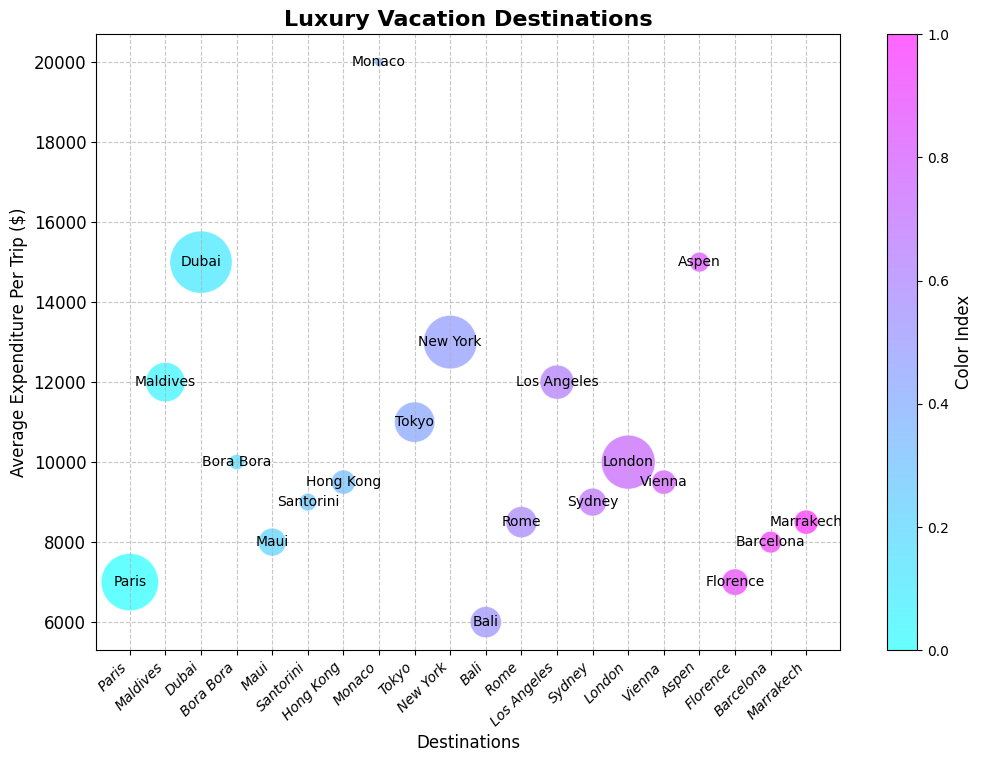Which destination has the highest average expenditure per trip? Identify the bubble with the highest position on the y-axis. Dubai has the highest y-value, representing the average expenditure per trip.
Answer: Dubai Which destination has the most five-star hotels? Identify the bubble with the largest size. Dubai’s bubble is the largest, representing the highest number of five-star hotels.
Answer: Dubai Compare the average expenditure per trip between Monaco and New York. Which is higher? Locate the bubbles for Monaco and New York and compare their y-positions. Monaco’s bubble is higher on the y-axis than New York’s.
Answer: Monaco What is the range of average expenditure per trip for destinations with visitor demographics aged 20-40? Identify the bubbles with visitor demographics 20-40 and note their y-axis values. Tokyo ($11,000) and Paris ($7,000) are in this range, so the range is $4,000.
Answer: $4,000 Which destination is visually associated with the third highest average expenditure per trip? Observe the bubbles from highest to third highest on the y-axis. New York is the third highest.
Answer: New York How does the number of five-star hotels in Vienna compare to the number in Tokyo? Compare the bubble sizes of Vienna and Tokyo visually. Tokyo’s bubble is larger, indicating more five-star hotels than Vienna.
Answer: Tokyo Estimate the difference in average expenditure per trip between Sydney and Paris. Find Sydney and Paris’s positions on the y-axis and calculate the difference ($9,000 - $7,000). The difference is $2,000.
Answer: $2,000 What is the expenditure gap between the least and most expensive destinations? Determine the highest and lowest points on the y-axis. The highest is Monaco ($20,000), and the lowest is Bali ($6,000). The gap is $14,000.
Answer: $14,000 Which bubble uses the darkest color on the color map? The bubble representing Dubai uses the darkest color, indicating the highest color index.
Answer: Dubai 